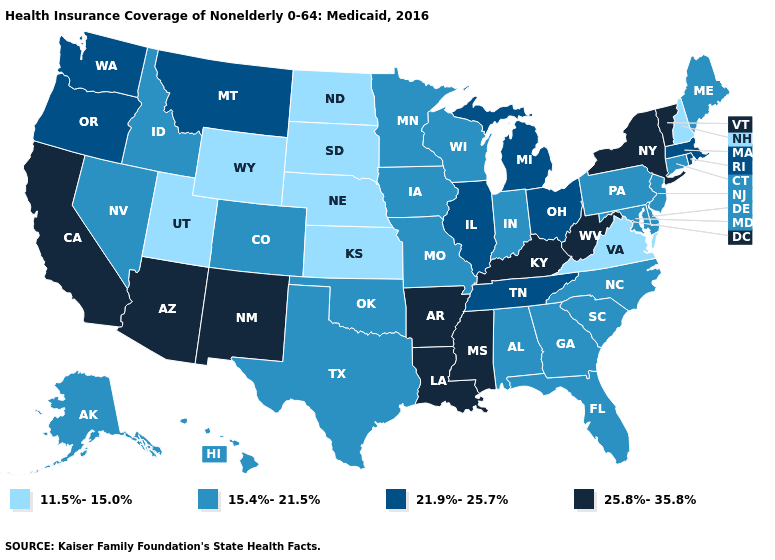Which states hav the highest value in the Northeast?
Concise answer only. New York, Vermont. Among the states that border Iowa , does Nebraska have the lowest value?
Write a very short answer. Yes. Name the states that have a value in the range 25.8%-35.8%?
Be succinct. Arizona, Arkansas, California, Kentucky, Louisiana, Mississippi, New Mexico, New York, Vermont, West Virginia. Name the states that have a value in the range 11.5%-15.0%?
Concise answer only. Kansas, Nebraska, New Hampshire, North Dakota, South Dakota, Utah, Virginia, Wyoming. Name the states that have a value in the range 21.9%-25.7%?
Be succinct. Illinois, Massachusetts, Michigan, Montana, Ohio, Oregon, Rhode Island, Tennessee, Washington. Which states have the lowest value in the USA?
Be succinct. Kansas, Nebraska, New Hampshire, North Dakota, South Dakota, Utah, Virginia, Wyoming. Does Maryland have a higher value than Wyoming?
Short answer required. Yes. What is the value of Massachusetts?
Quick response, please. 21.9%-25.7%. Name the states that have a value in the range 21.9%-25.7%?
Short answer required. Illinois, Massachusetts, Michigan, Montana, Ohio, Oregon, Rhode Island, Tennessee, Washington. What is the value of Indiana?
Be succinct. 15.4%-21.5%. What is the lowest value in states that border New Hampshire?
Quick response, please. 15.4%-21.5%. What is the value of California?
Keep it brief. 25.8%-35.8%. Does Massachusetts have a lower value than Arkansas?
Answer briefly. Yes. Which states have the lowest value in the USA?
Concise answer only. Kansas, Nebraska, New Hampshire, North Dakota, South Dakota, Utah, Virginia, Wyoming. Name the states that have a value in the range 21.9%-25.7%?
Answer briefly. Illinois, Massachusetts, Michigan, Montana, Ohio, Oregon, Rhode Island, Tennessee, Washington. 